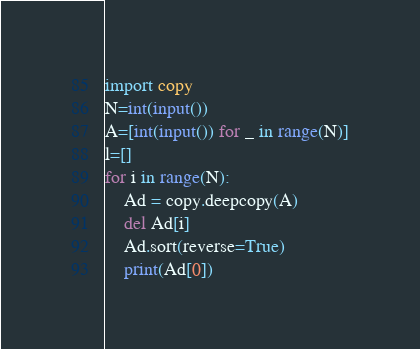<code> <loc_0><loc_0><loc_500><loc_500><_Python_>import copy
N=int(input())
A=[int(input()) for _ in range(N)]
l=[]
for i in range(N):
    Ad = copy.deepcopy(A)
    del Ad[i]
    Ad.sort(reverse=True)
    print(Ad[0])
</code> 